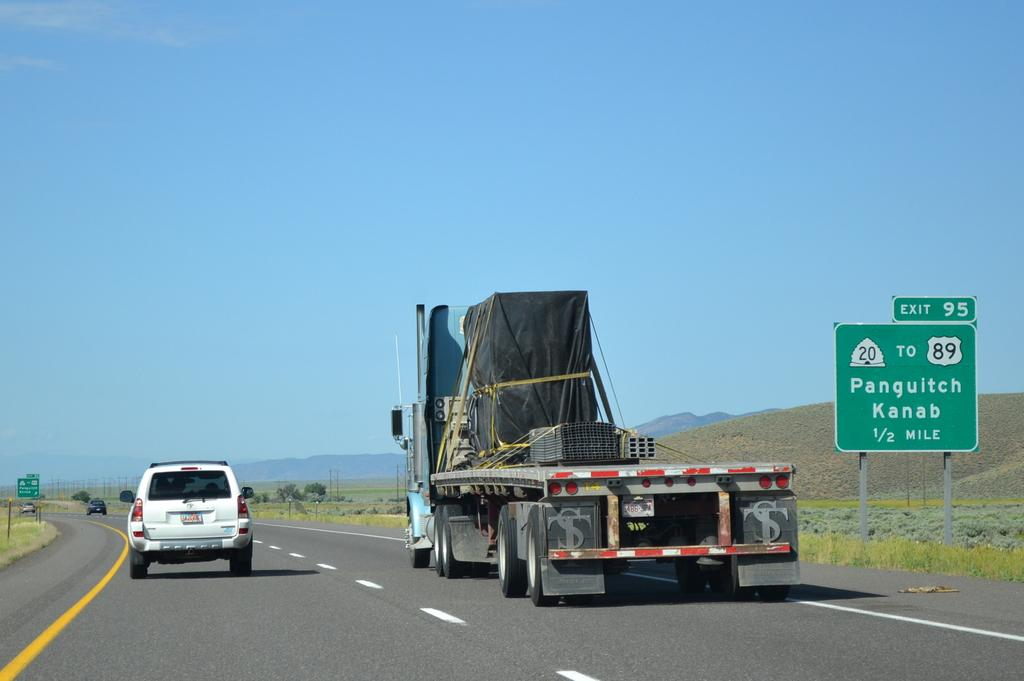What can be seen on the road in the image? There are vehicles on the road in the image. What type of vegetation is visible in the image? There is grass, plants, and trees visible in the image. What structures can be seen in the image? There are boards and poles in the image. What natural features are present in the image? There are mountains in the image. What is visible in the background of the image? The sky is visible in the background of the image. Are there any giants visible in the image? No, there are no giants present in the image. Can you see a tramp performing in the image? No, there is no tramp performing in the image. 